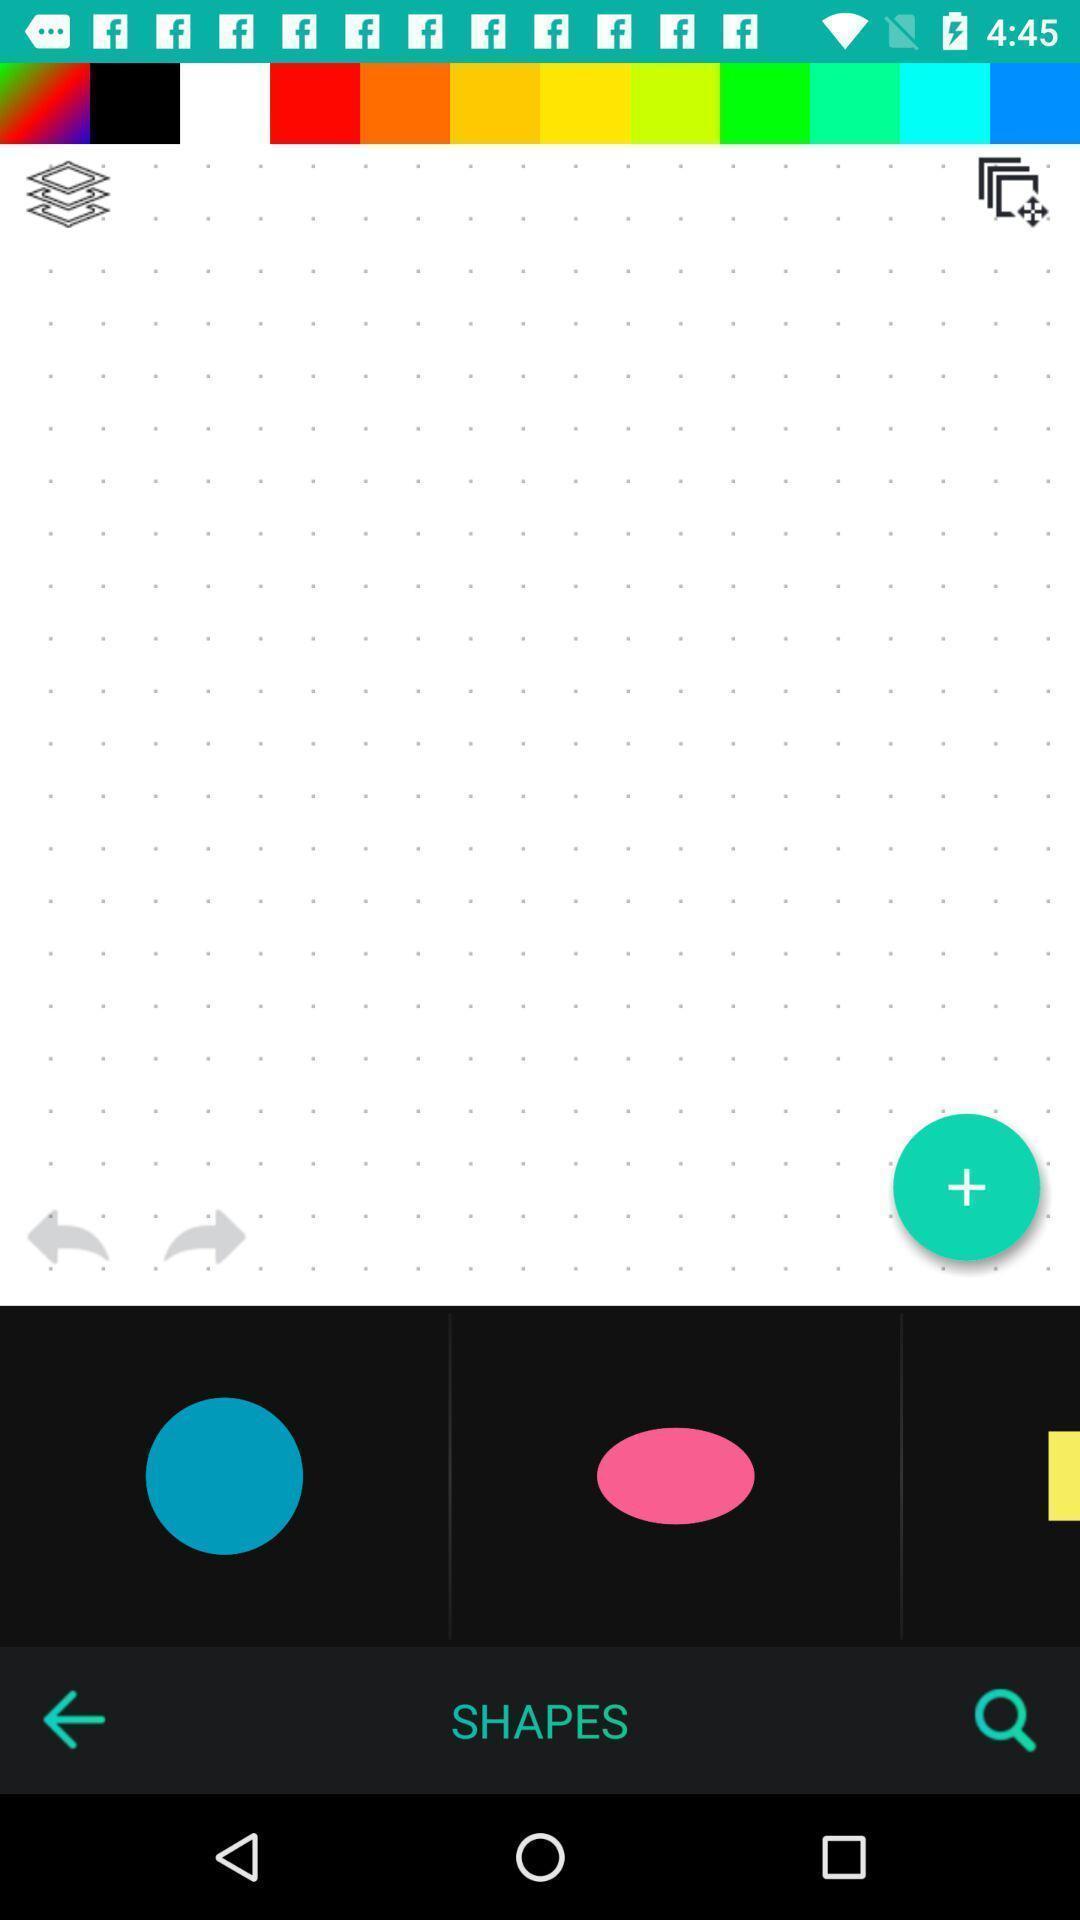What details can you identify in this image? Screen displaying multiple controls in a logo editing application. 